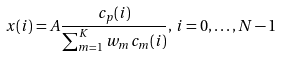<formula> <loc_0><loc_0><loc_500><loc_500>x ( i ) = A \frac { c _ { p } ( i ) } { \sum _ { m = 1 } ^ { K } w _ { m } c _ { m } ( i ) } , \, i = 0 , \dots , N - 1</formula> 